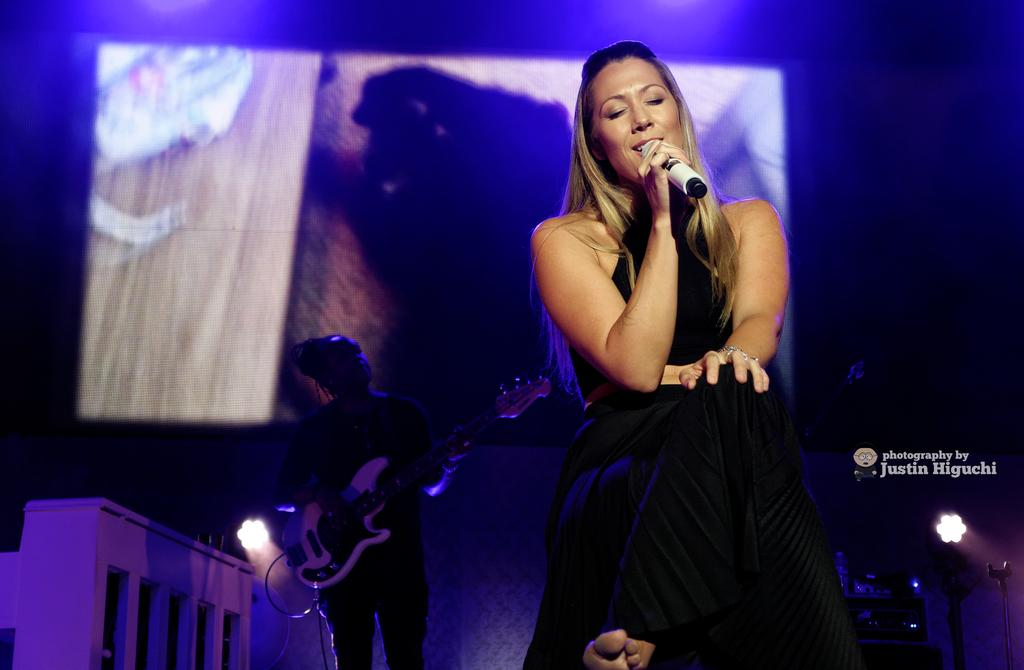Who is the main subject in the image? There is a woman in the image. What is the woman holding in the image? The woman is holding a mic. Can you describe the background of the image? There is a person visible in the background, along with a guitar, a screen, lights, and some objects. The background is dark. What type of cloth is draped over the bridge in the image? There is no bridge present in the image, and therefore no cloth draped over it. 